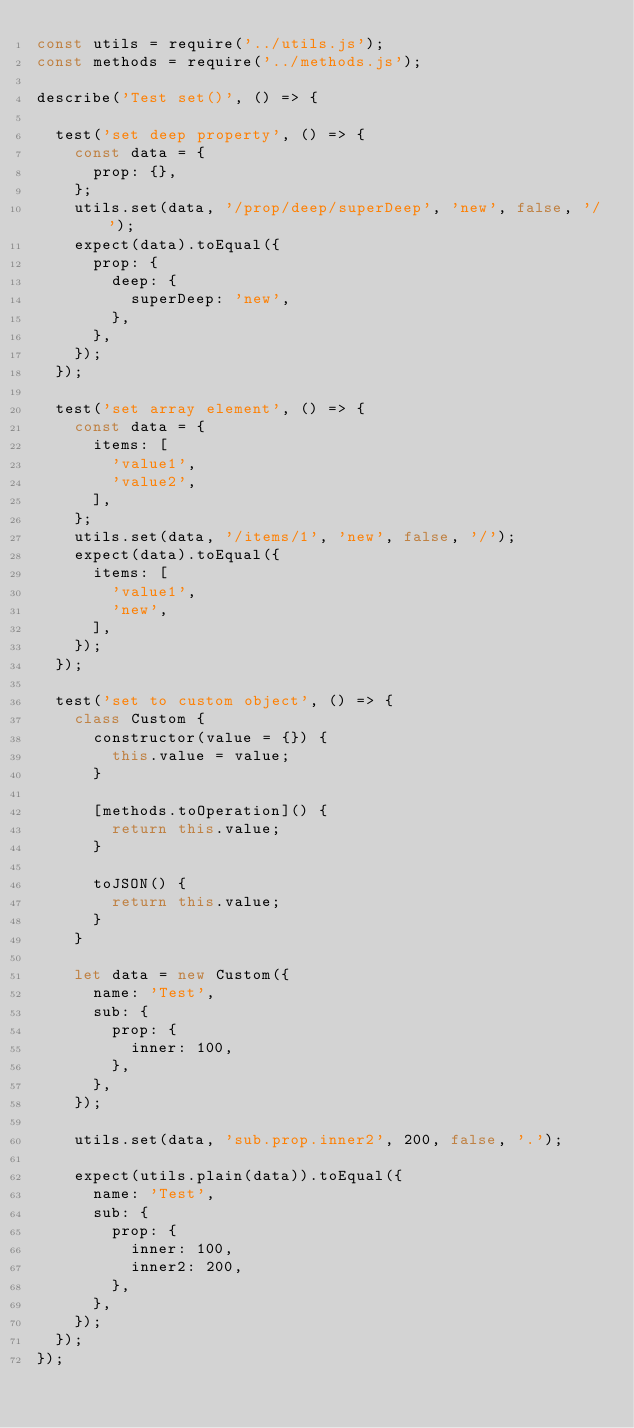<code> <loc_0><loc_0><loc_500><loc_500><_JavaScript_>const utils = require('../utils.js');
const methods = require('../methods.js');

describe('Test set()', () => {

  test('set deep property', () => {
    const data = {
      prop: {},
    };
    utils.set(data, '/prop/deep/superDeep', 'new', false, '/');
    expect(data).toEqual({
      prop: {
        deep: {
          superDeep: 'new',
        },
      },
    });
  });

  test('set array element', () => {
    const data = {
      items: [
        'value1',
        'value2',
      ],
    };
    utils.set(data, '/items/1', 'new', false, '/');
    expect(data).toEqual({
      items: [
        'value1',
        'new',
      ],
    });
  });

  test('set to custom object', () => {
    class Custom {
      constructor(value = {}) {
        this.value = value;
      }

      [methods.toOperation]() {
        return this.value;
      }

      toJSON() {
        return this.value;
      }
    }

    let data = new Custom({
      name: 'Test',
      sub: {
        prop: {
          inner: 100,
        },
      },
    });

    utils.set(data, 'sub.prop.inner2', 200, false, '.');

    expect(utils.plain(data)).toEqual({
      name: 'Test',
      sub: {
        prop: {
          inner: 100,
          inner2: 200,
        },
      },
    });
  });
});

</code> 